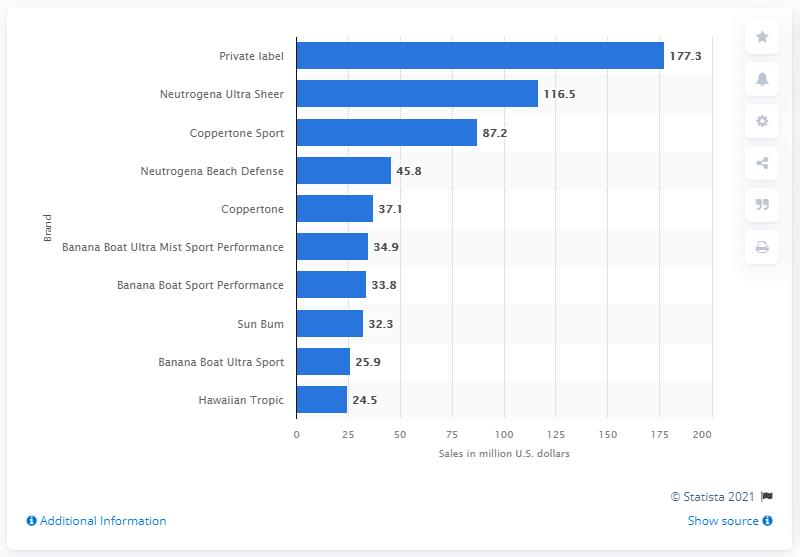Mention a couple of crucial points in this snapshot. Neutrogena Ultra Sheer generated $116.5 million in sales in 2019. Neutrogena Ultra Sheer is the leading name brand of suntan lotion and suntan oil in the United States. In 2019, private label suntan lotions sold for a total of 177.3 million dollars in the United States. 